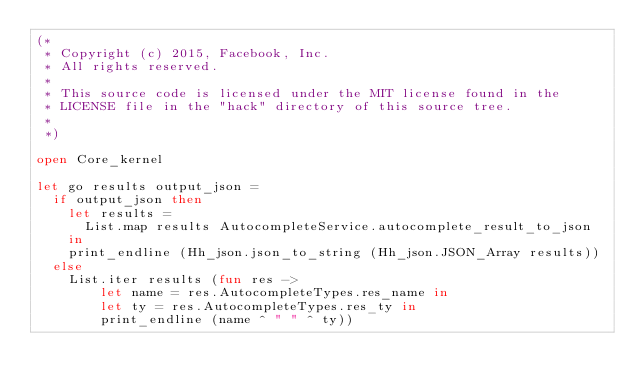<code> <loc_0><loc_0><loc_500><loc_500><_OCaml_>(*
 * Copyright (c) 2015, Facebook, Inc.
 * All rights reserved.
 *
 * This source code is licensed under the MIT license found in the
 * LICENSE file in the "hack" directory of this source tree.
 *
 *)

open Core_kernel

let go results output_json =
  if output_json then
    let results =
      List.map results AutocompleteService.autocomplete_result_to_json
    in
    print_endline (Hh_json.json_to_string (Hh_json.JSON_Array results))
  else
    List.iter results (fun res ->
        let name = res.AutocompleteTypes.res_name in
        let ty = res.AutocompleteTypes.res_ty in
        print_endline (name ^ " " ^ ty))
</code> 